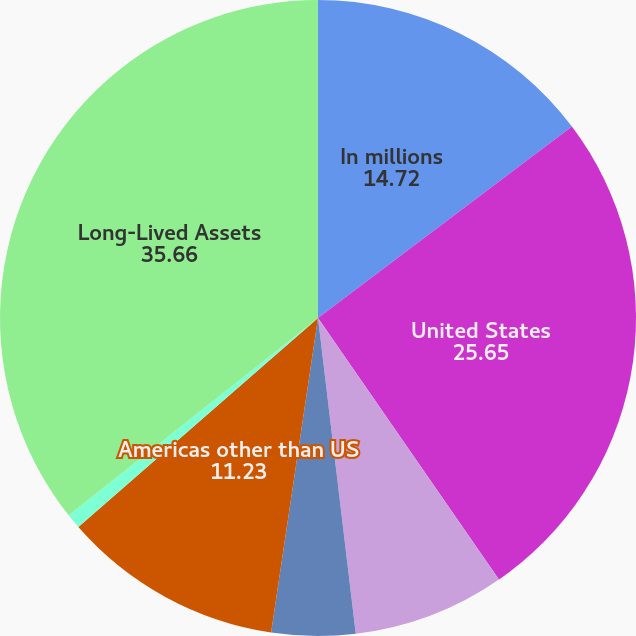Convert chart to OTSL. <chart><loc_0><loc_0><loc_500><loc_500><pie_chart><fcel>In millions<fcel>United States<fcel>Europe<fcel>Pacific Rim and Asia<fcel>Americas other than US<fcel>Corporate<fcel>Long-Lived Assets<nl><fcel>14.72%<fcel>25.65%<fcel>7.74%<fcel>4.25%<fcel>11.23%<fcel>0.76%<fcel>35.66%<nl></chart> 